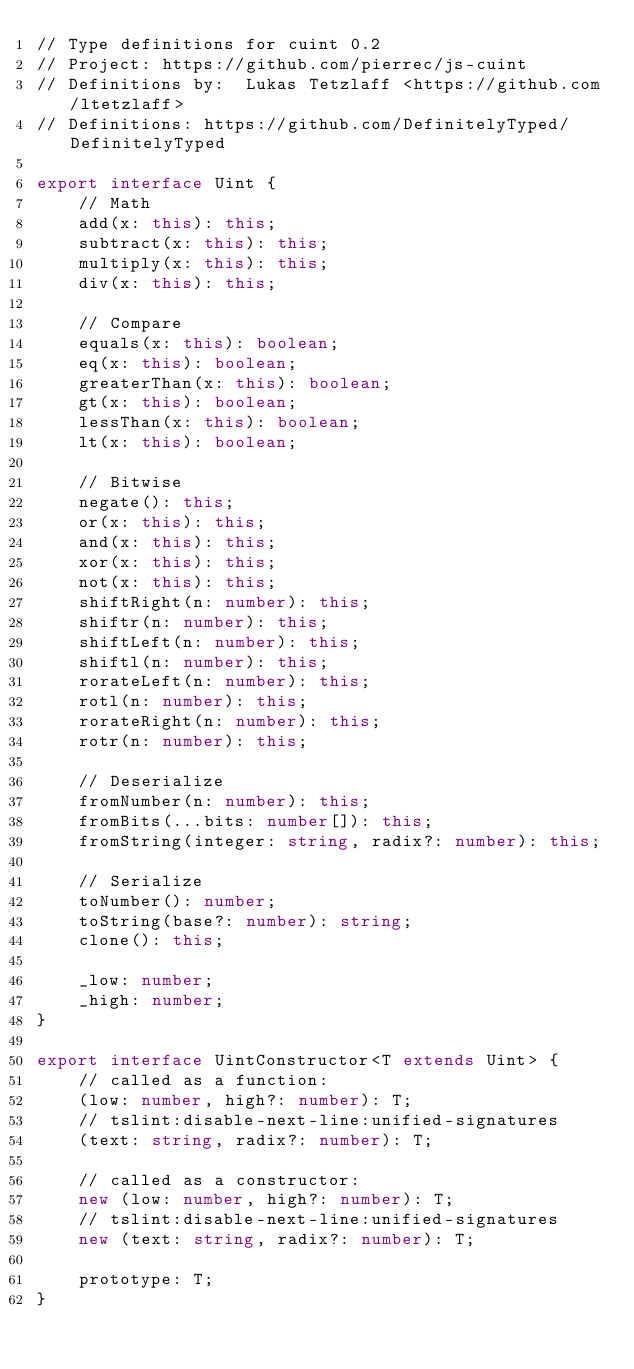<code> <loc_0><loc_0><loc_500><loc_500><_TypeScript_>// Type definitions for cuint 0.2
// Project: https://github.com/pierrec/js-cuint
// Definitions by:  Lukas Tetzlaff <https://github.com/ltetzlaff>
// Definitions: https://github.com/DefinitelyTyped/DefinitelyTyped

export interface Uint {
    // Math
    add(x: this): this;
    subtract(x: this): this;
    multiply(x: this): this;
    div(x: this): this;

    // Compare
    equals(x: this): boolean;
    eq(x: this): boolean;
    greaterThan(x: this): boolean;
    gt(x: this): boolean;
    lessThan(x: this): boolean;
    lt(x: this): boolean;

    // Bitwise
    negate(): this;
    or(x: this): this;
    and(x: this): this;
    xor(x: this): this;
    not(x: this): this;
    shiftRight(n: number): this;
    shiftr(n: number): this;
    shiftLeft(n: number): this;
    shiftl(n: number): this;
    rorateLeft(n: number): this;
    rotl(n: number): this;
    rorateRight(n: number): this;
    rotr(n: number): this;

    // Deserialize
    fromNumber(n: number): this;
    fromBits(...bits: number[]): this;
    fromString(integer: string, radix?: number): this;

    // Serialize
    toNumber(): number;
    toString(base?: number): string;
    clone(): this;

    _low: number;
    _high: number;
}

export interface UintConstructor<T extends Uint> {
    // called as a function:
    (low: number, high?: number): T;
    // tslint:disable-next-line:unified-signatures
    (text: string, radix?: number): T;

    // called as a constructor:
    new (low: number, high?: number): T;
    // tslint:disable-next-line:unified-signatures
    new (text: string, radix?: number): T;

    prototype: T;
}
</code> 